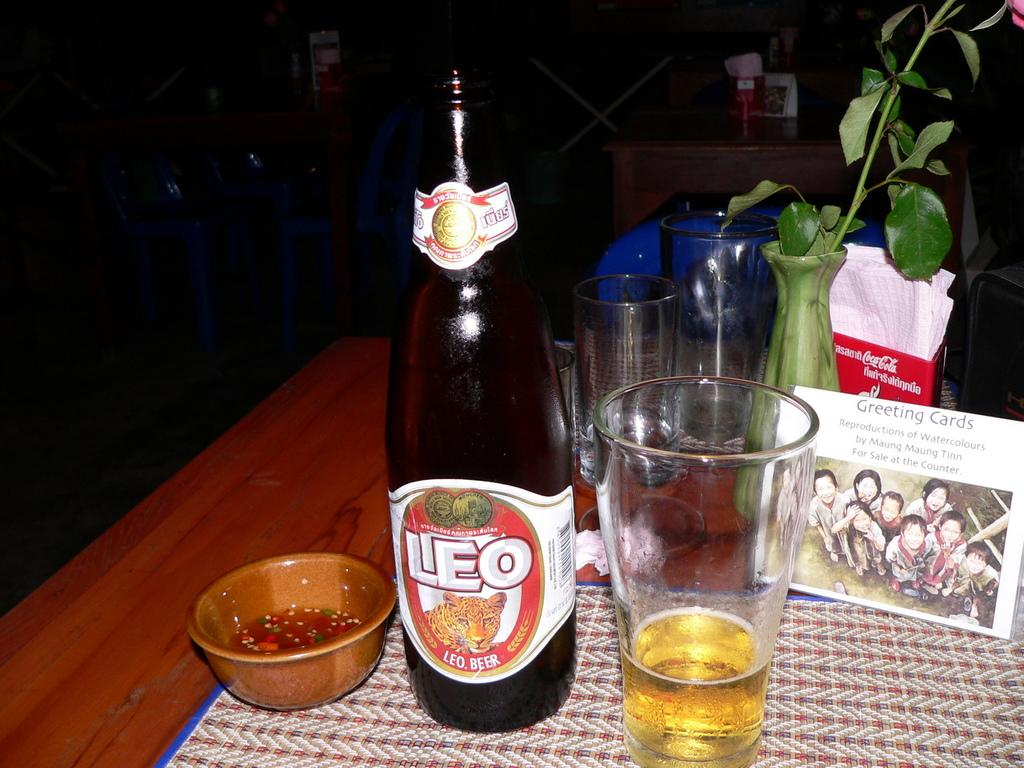<image>
Present a compact description of the photo's key features. A glass of beer sits next to a bottle that says LEO on a table 